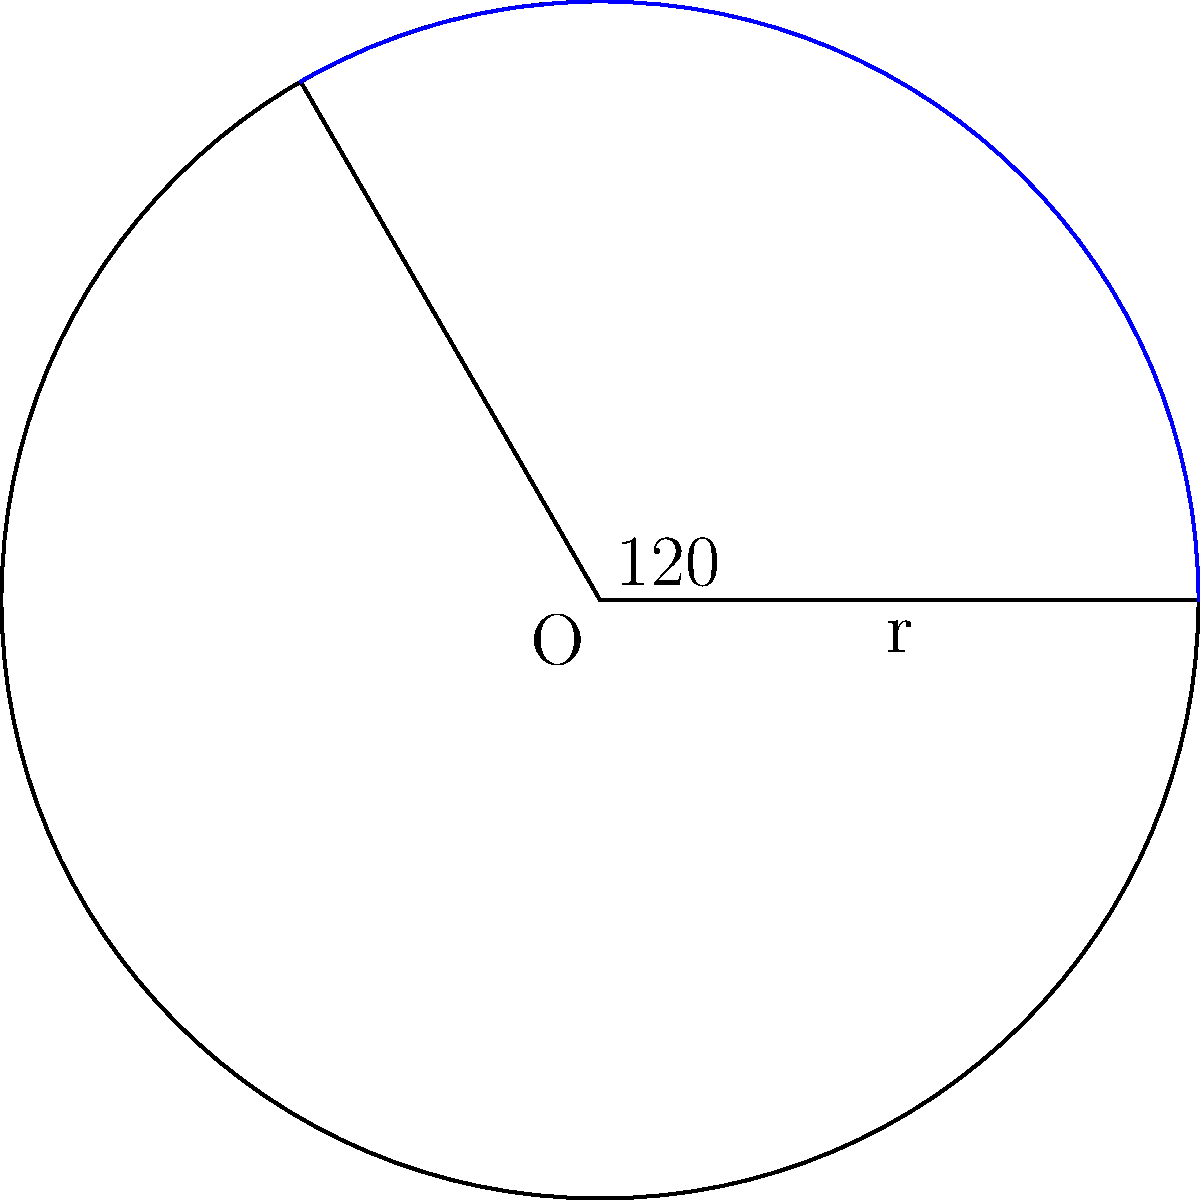A circular sector has a central angle of 120° and a radius of 5 cm. Calculate the area of this sector, rounding your answer to two decimal places. To find the area of a circular sector, we can follow these steps:

1) The formula for the area of a circular sector is:

   $$A = \frac{\theta}{360°} \pi r^2$$

   Where $A$ is the area, $\theta$ is the central angle in degrees, and $r$ is the radius.

2) We are given:
   $\theta = 120°$
   $r = 5$ cm

3) Let's substitute these values into our formula:

   $$A = \frac{120°}{360°} \pi (5\text{ cm})^2$$

4) Simplify:
   $$A = \frac{1}{3} \pi (25\text{ cm}^2)$$

5) Calculate:
   $$A = \frac{1}{3} \times 3.14159... \times 25\text{ cm}^2$$
   $$A \approx 26.18\text{ cm}^2$$

6) Rounding to two decimal places:
   $$A \approx 26.18\text{ cm}^2$$
Answer: 26.18 cm² 